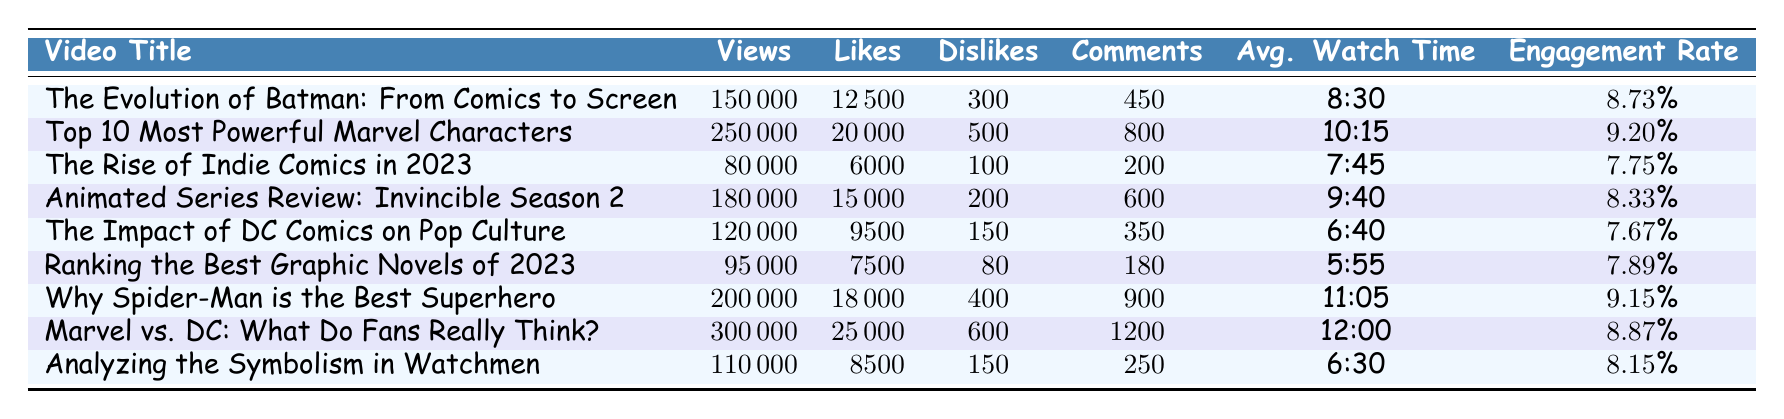What is the engagement rate of the video titled "The Impact of DC Comics on Pop Culture"? The engagement rate is directly mentioned in the table under the respective video's row. For "The Impact of DC Comics on Pop Culture," it is listed as 7.67%.
Answer: 7.67% How many dislikes did the video "*Top 10 Most Powerful Marvel Characters*" receive? The number of dislikes for this video is specifically noted in the table, which states that it received 500 dislikes.
Answer: 500 Which video had the highest number of views? By comparing the views column across all videos, "Marvel vs. DC: What Do Fans Really Think?" has the highest views at 300,000.
Answer: 300,000 What is the average watch time of the video titled "Why Spider-Man is the Best Superhero"? The average watch time for this video is found in the corresponding row of the table, and it is listed as 11:05.
Answer: 11:05 What is the total number of likes for all videos listed in the table? To find the total likes, sum the likes from each video: 12500 + 20000 + 6000 + 15000 + 9500 + 7500 + 18000 + 25000 + 8500 = 115000.
Answer: 115000 Which video had the lowest engagement rate and what was that rate? By examining the engagement rates for each video, "The Rise of Indie Comics in 2023" has the lowest engagement rate at 7.75%.
Answer: 7.75% Is the average watch time longer for "Marvel vs. DC: What Do Fans Really Think?" compared to "The Rise of Indie Comics in 2023"? For comparison, the average watch time for "Marvel vs. DC: What Do Fans Really Think?" is 12:00, while for "The Rise of Indie Comics in 2023," it is 7:45. Since 12:00 is greater than 7:45, the statement is true.
Answer: Yes How many more comments did "Marvel vs. DC: What Do Fans Really Think?" receive than "Analyzing the Symbolism in Watchmen"? The comments for "Marvel vs. DC: What Do Fans Really Think?" are 1200 while for "Analyzing the Symbolism in Watchmen," there are 250 comments. The difference is 1200 - 250 = 950.
Answer: 950 What percentage of people who viewed "*The Evolution of Batman: From Comics to Screen*" liked the video? To find the percentage of likers, divide the number of likes (12500) by the number of views (150000), then multiply by 100. (12500 / 150000) * 100 = 8.33%.
Answer: 8.33% Which video had more comments: "*Animated Series Review: Invincible Season 2*" or "*The Impact of DC Comics on Pop Culture*"? The first video received 600 comments and the second one received 350 comments. Since 600 is greater than 350, the first video had more comments.
Answer: Animated Series Review: Invincible Season 2 